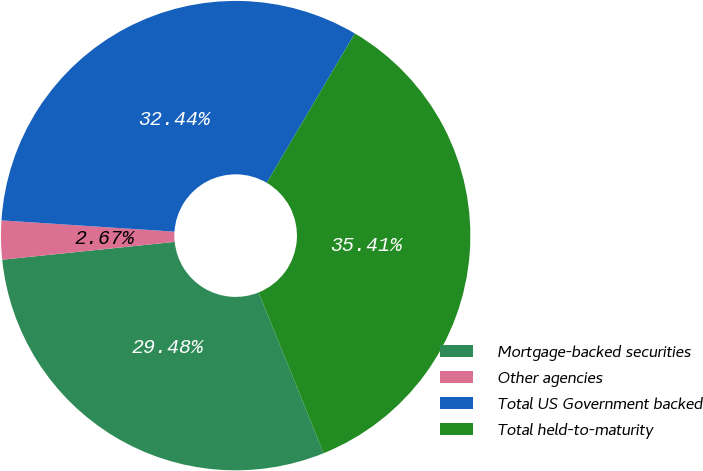<chart> <loc_0><loc_0><loc_500><loc_500><pie_chart><fcel>Mortgage-backed securities<fcel>Other agencies<fcel>Total US Government backed<fcel>Total held-to-maturity<nl><fcel>29.48%<fcel>2.67%<fcel>32.44%<fcel>35.41%<nl></chart> 